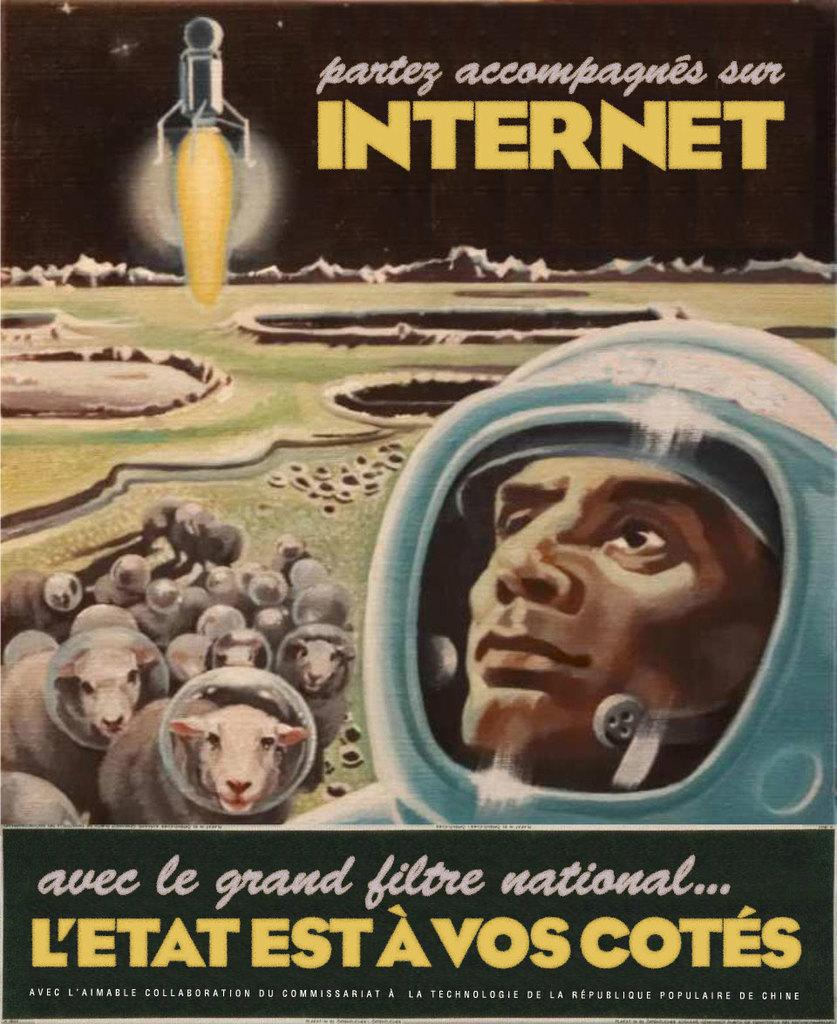<image>
Give a short and clear explanation of the subsequent image. a book cover for the internet depicting a man and sheep on the moon 